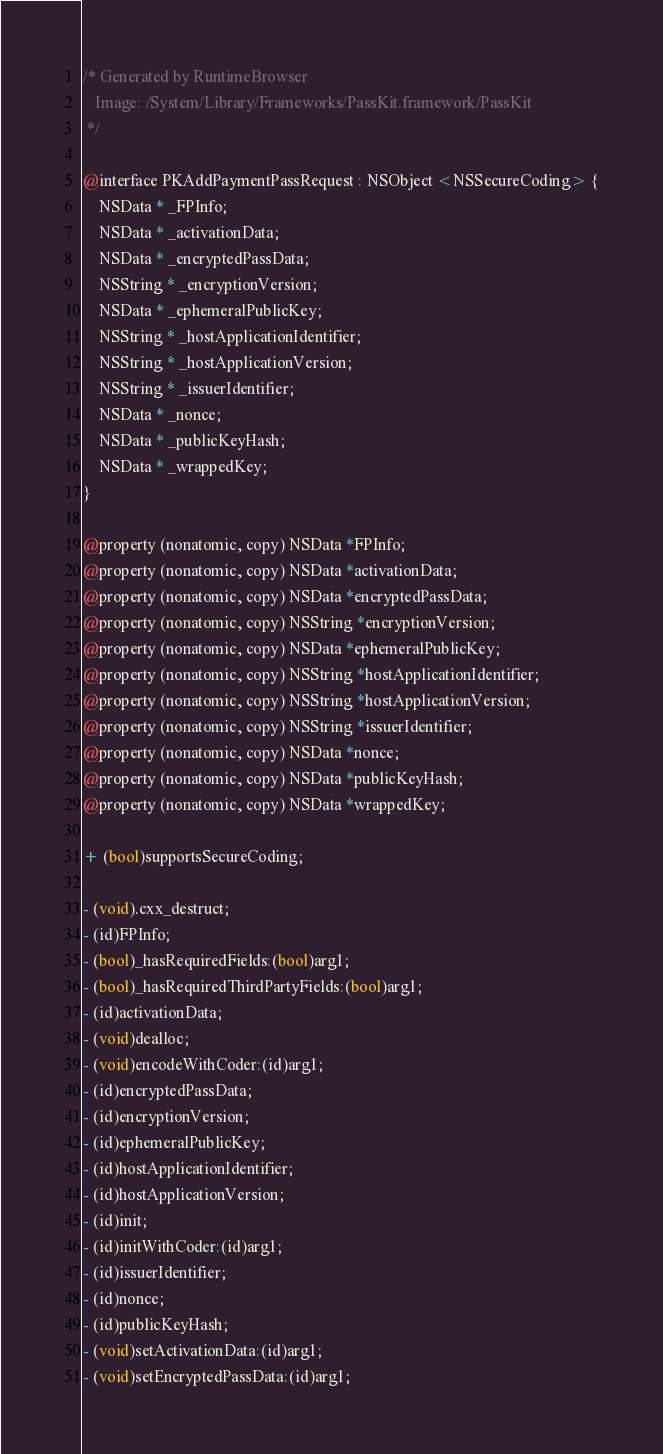<code> <loc_0><loc_0><loc_500><loc_500><_C_>/* Generated by RuntimeBrowser
   Image: /System/Library/Frameworks/PassKit.framework/PassKit
 */

@interface PKAddPaymentPassRequest : NSObject <NSSecureCoding> {
    NSData * _FPInfo;
    NSData * _activationData;
    NSData * _encryptedPassData;
    NSString * _encryptionVersion;
    NSData * _ephemeralPublicKey;
    NSString * _hostApplicationIdentifier;
    NSString * _hostApplicationVersion;
    NSString * _issuerIdentifier;
    NSData * _nonce;
    NSData * _publicKeyHash;
    NSData * _wrappedKey;
}

@property (nonatomic, copy) NSData *FPInfo;
@property (nonatomic, copy) NSData *activationData;
@property (nonatomic, copy) NSData *encryptedPassData;
@property (nonatomic, copy) NSString *encryptionVersion;
@property (nonatomic, copy) NSData *ephemeralPublicKey;
@property (nonatomic, copy) NSString *hostApplicationIdentifier;
@property (nonatomic, copy) NSString *hostApplicationVersion;
@property (nonatomic, copy) NSString *issuerIdentifier;
@property (nonatomic, copy) NSData *nonce;
@property (nonatomic, copy) NSData *publicKeyHash;
@property (nonatomic, copy) NSData *wrappedKey;

+ (bool)supportsSecureCoding;

- (void).cxx_destruct;
- (id)FPInfo;
- (bool)_hasRequiredFields:(bool)arg1;
- (bool)_hasRequiredThirdPartyFields:(bool)arg1;
- (id)activationData;
- (void)dealloc;
- (void)encodeWithCoder:(id)arg1;
- (id)encryptedPassData;
- (id)encryptionVersion;
- (id)ephemeralPublicKey;
- (id)hostApplicationIdentifier;
- (id)hostApplicationVersion;
- (id)init;
- (id)initWithCoder:(id)arg1;
- (id)issuerIdentifier;
- (id)nonce;
- (id)publicKeyHash;
- (void)setActivationData:(id)arg1;
- (void)setEncryptedPassData:(id)arg1;</code> 